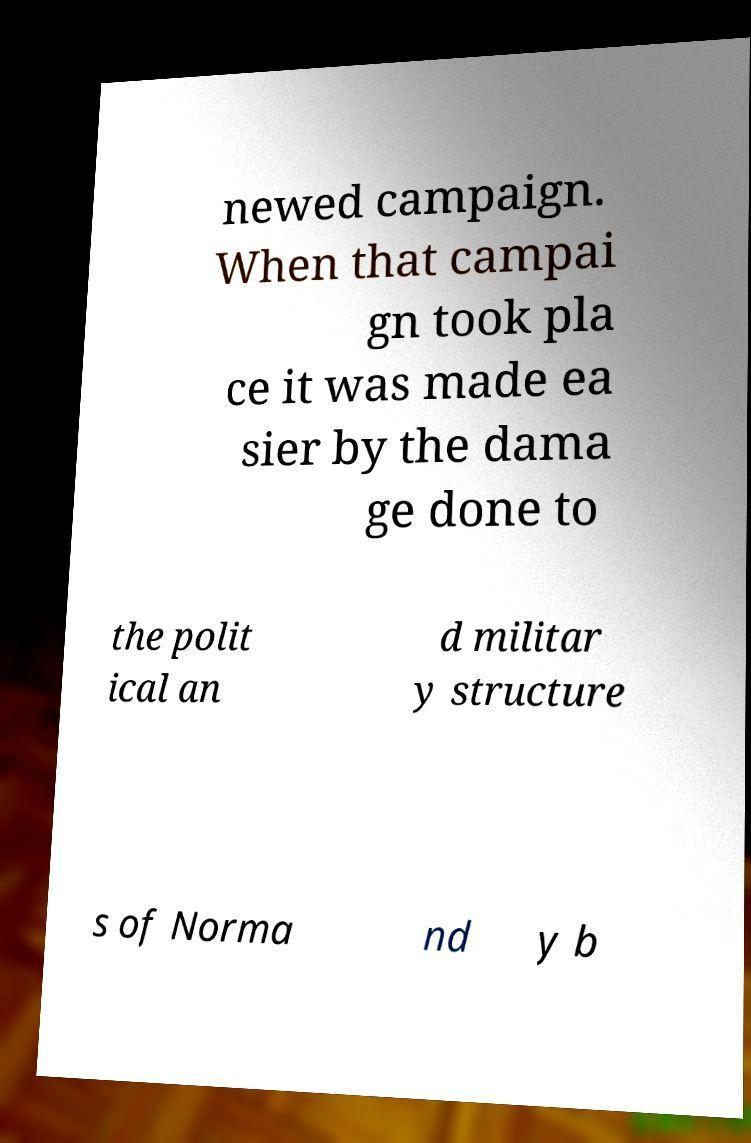Could you assist in decoding the text presented in this image and type it out clearly? newed campaign. When that campai gn took pla ce it was made ea sier by the dama ge done to the polit ical an d militar y structure s of Norma nd y b 